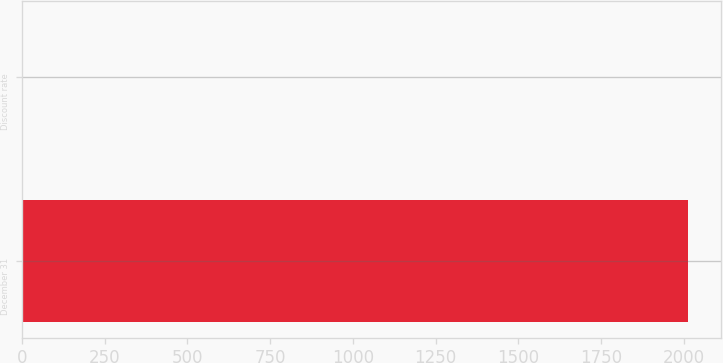<chart> <loc_0><loc_0><loc_500><loc_500><bar_chart><fcel>December 31<fcel>Discount rate<nl><fcel>2013<fcel>4.5<nl></chart> 